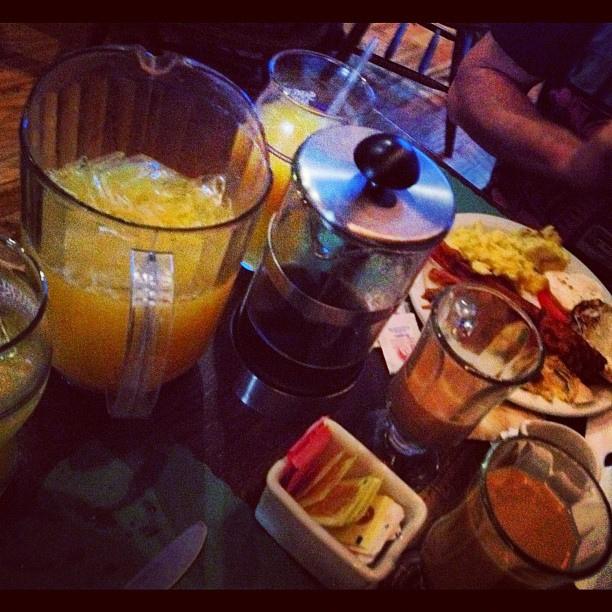What is inside the glass cubes?
Be succinct. Orange juice. What is the coffee maker next to the OJ called?
Concise answer only. French press. Is there anyone eating?
Keep it brief. Yes. Are there eggs on the plate?
Answer briefly. Yes. 